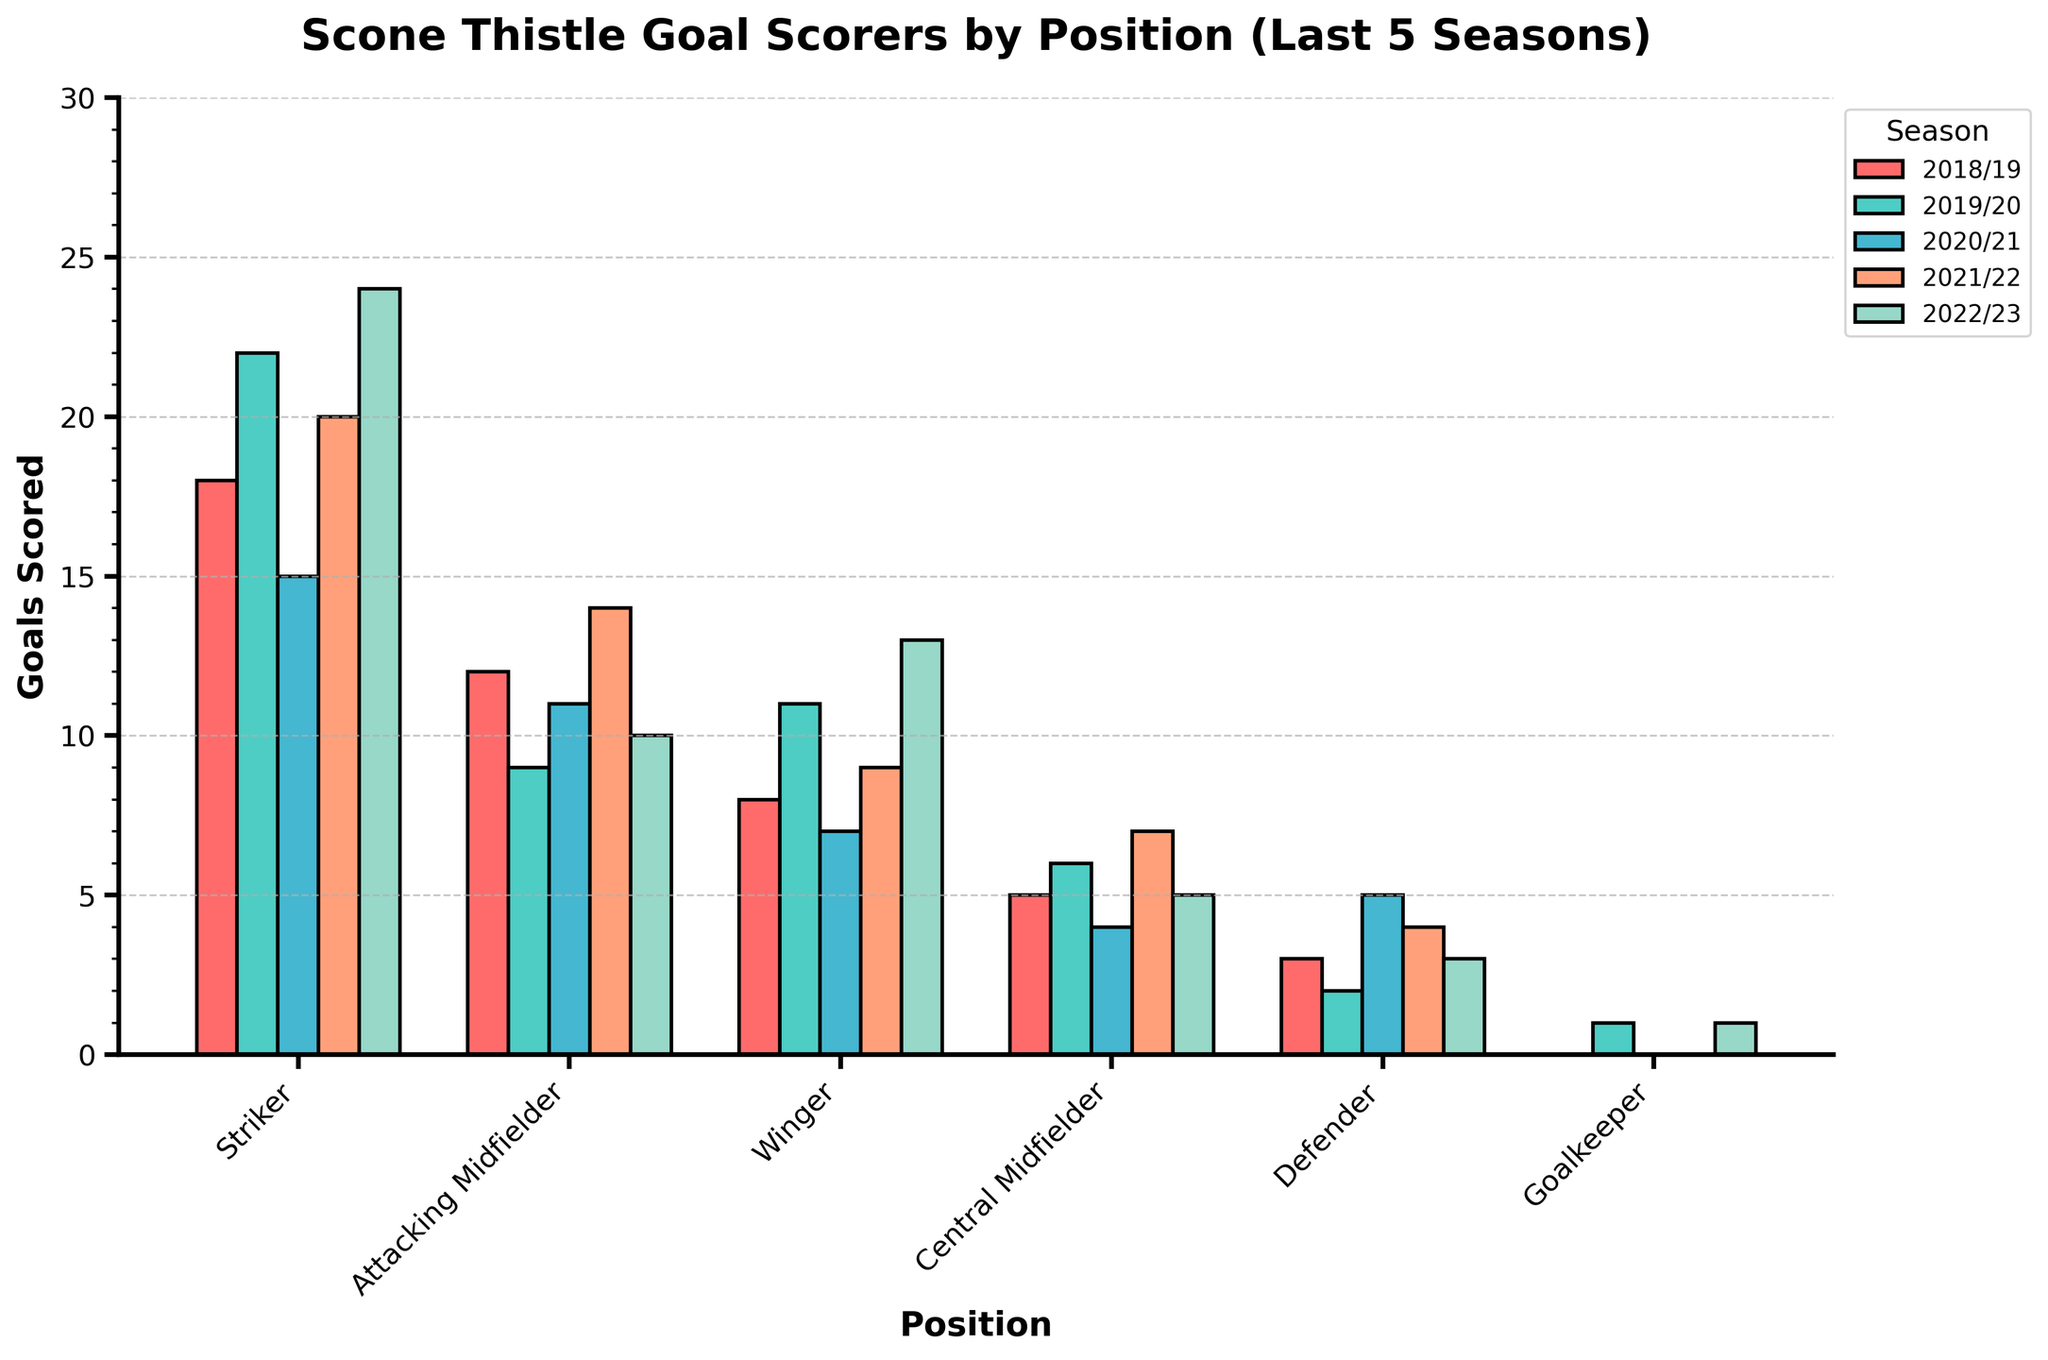Which position scored the most goals in the 2022/23 season? To find this, compare the heights of the bars for each position in the 2022/23 season. The Striker has the highest bar.
Answer: Striker How many goals did Central Midfielders score in total over the five seasons? Sum the bars for Central Midfielders for each of the five seasons: 5 (2018/19) + 6 (2019/20) + 4 (2020/21) + 7 (2021/22) + 5 (2022/23) = 27.
Answer: 27 Which season did Attacking Midfielders score the least, and how many goals were scored? To find this, compare the heights of the bars for Attacking Midfielders across the five seasons. The shortest bar is for the 2019/20 season. The height of this bar (goals scored) is 9.
Answer: 2019/20, 9 Did Defenders score more goals in the 2020/21 season compared to the 2019/20 season? Check the heights of the bars for Defenders in both the 2019/20 and 2020/21 seasons. The 2020/21 bar is higher (5 goals) compared to 2019/20 (2 goals).
Answer: Yes What is the average number of goals scored by the Winger position over the five seasons? Sum the bars for the Winger position for each of the five seasons: 8 (2018/19) + 11 (2019/20) + 7 (2020/21) + 9 (2021/22) + 13 (2022/23) = 48. Average = 48/5 = 9.6.
Answer: 9.6 Which position had the least variance in goals scored over the five seasons? To find the position with the least variance, observe the bars for each position across the five seasons. Defender and Goalkeeper have relatively stable bars, but the Goalkeeper has minimal fluctuation.
Answer: Goalkeeper In which season were the total goals scored the highest for all positions combined? Sum the heights of the bars for all positions for each season and compare. For 2018/19: 18 + 12 + 8 + 5 + 3 + 0 = 46, for 2019/20: 22 + 9 + 11 + 6 + 2 + 1 = 51, for 2020/21: 15 + 11 + 7 + 4 + 5 + 0 = 42, for 2021/22: 20 + 14 + 9 + 7 + 4 + 0 = 54, for 2022/23: 24 + 10 + 13 + 5 + 3 + 1 = 56. The highest is for 2022/23 season.
Answer: 2022/23 How did the number of goals by the Striker position change from the 2020/21 season to the 2021/22 season? Look at the heights of the bars for Strikers in 2020/21 (15 goals) and 2021/22 (20 goals). The change is 20 - 15 = 5.
Answer: Increased by 5 